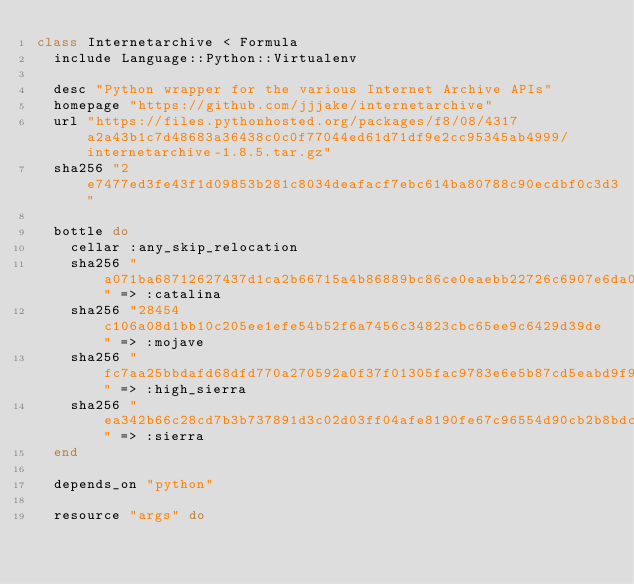<code> <loc_0><loc_0><loc_500><loc_500><_Ruby_>class Internetarchive < Formula
  include Language::Python::Virtualenv

  desc "Python wrapper for the various Internet Archive APIs"
  homepage "https://github.com/jjjake/internetarchive"
  url "https://files.pythonhosted.org/packages/f8/08/4317a2a43b1c7d48683a36438c0c0f77044ed61d71df9e2cc95345ab4999/internetarchive-1.8.5.tar.gz"
  sha256 "2e7477ed3fe43f1d09853b281c8034deafacf7ebc614ba80788c90ecdbf0c3d3"

  bottle do
    cellar :any_skip_relocation
    sha256 "a071ba68712627437d1ca2b66715a4b86889bc86ce0eaebb22726c6907e6da02" => :catalina
    sha256 "28454c106a08d1bb10c205ee1efe54b52f6a7456c34823cbc65ee9c6429d39de" => :mojave
    sha256 "fc7aa25bbdafd68dfd770a270592a0f37f01305fac9783e6e5b87cd5eabd9f9f" => :high_sierra
    sha256 "ea342b66c28cd7b3b737891d3c02d03ff04afe8190fe67c96554d90cb2b8bdc0" => :sierra
  end

  depends_on "python"

  resource "args" do</code> 